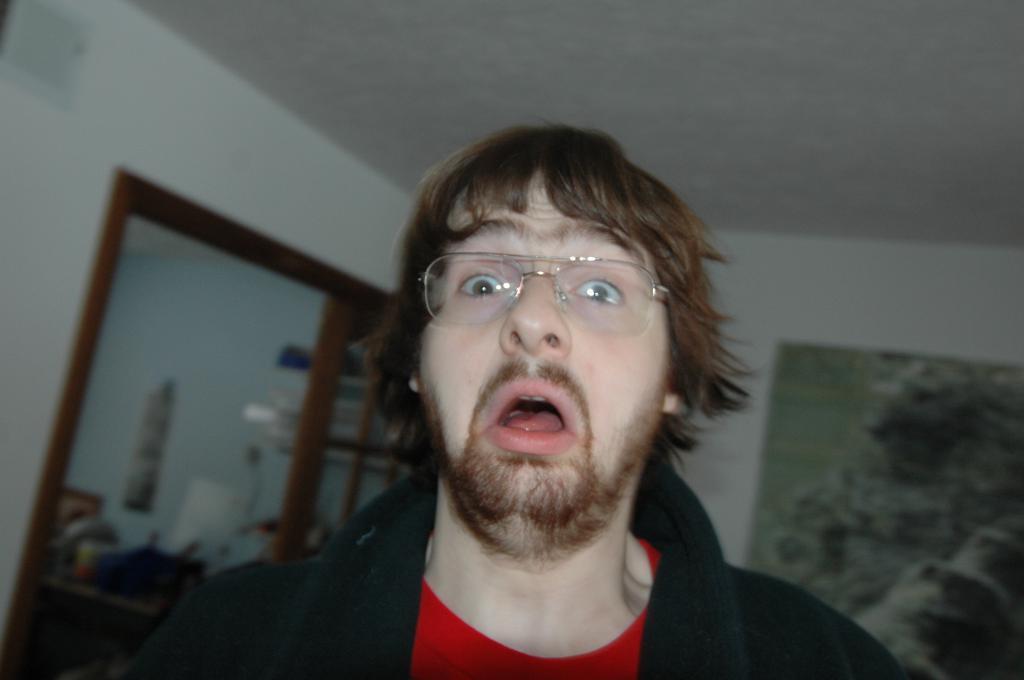Could you give a brief overview of what you see in this image? In this image there is a man standing in room is giving shocked expressions behind him there are so many things. 